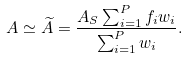Convert formula to latex. <formula><loc_0><loc_0><loc_500><loc_500>A \simeq \widetilde { A } = \frac { A _ { S } \sum _ { i = 1 } ^ { P } f _ { i } w _ { i } } { \sum _ { i = 1 } ^ { P } w _ { i } } .</formula> 